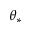<formula> <loc_0><loc_0><loc_500><loc_500>\theta _ { * }</formula> 